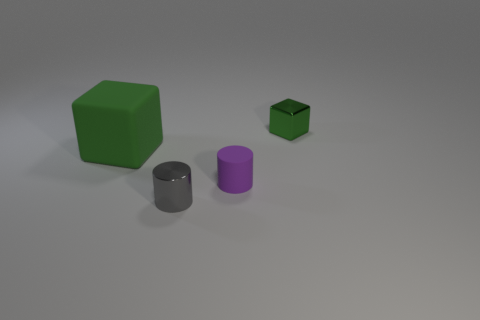There is a purple cylinder that is the same size as the gray cylinder; what material is it?
Provide a short and direct response. Rubber. How many other things are the same material as the gray cylinder?
Give a very brief answer. 1. There is a green thing that is on the right side of the big green object; what is its size?
Ensure brevity in your answer.  Small. How many things are both right of the small gray metal cylinder and behind the tiny matte cylinder?
Your response must be concise. 1. What is the material of the small cylinder that is behind the small cylinder that is left of the matte cylinder?
Ensure brevity in your answer.  Rubber. What is the material of the purple thing that is the same shape as the gray thing?
Offer a very short reply. Rubber. Are there any gray metallic balls?
Offer a very short reply. No. What shape is the object that is the same material as the tiny block?
Ensure brevity in your answer.  Cylinder. There is a block on the right side of the big green object; what is it made of?
Keep it short and to the point. Metal. Is the color of the small cylinder on the left side of the small purple cylinder the same as the rubber cylinder?
Ensure brevity in your answer.  No. 